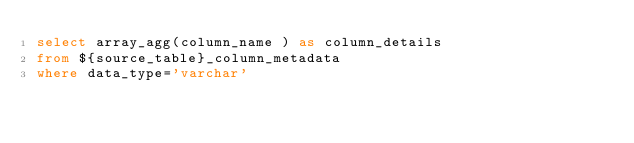Convert code to text. <code><loc_0><loc_0><loc_500><loc_500><_SQL_>select array_agg(column_name ) as column_details
from ${source_table}_column_metadata
where data_type='varchar'</code> 